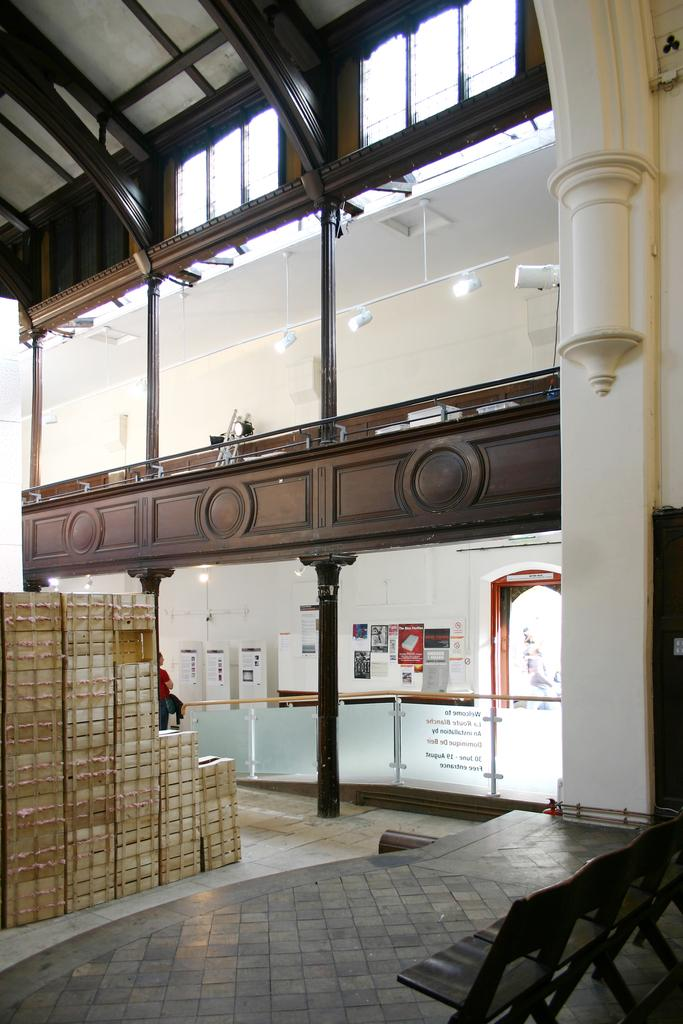What type of objects can be seen on the floor in the image? There are boxes, chairs, poles, lights, glasses, and posters on the floor in the image. What can be found on the wall in the background of the image? There is no information about the wall in the background of the image. How many different types of objects are on the floor in the image? There are six different types of objects on the floor in the image: boxes, chairs, poles, lights, glasses, and posters. What month is it in the image? There is no information about the month in the image. How does the knee of the person in the image feel? There is no person or knee present in the image. 